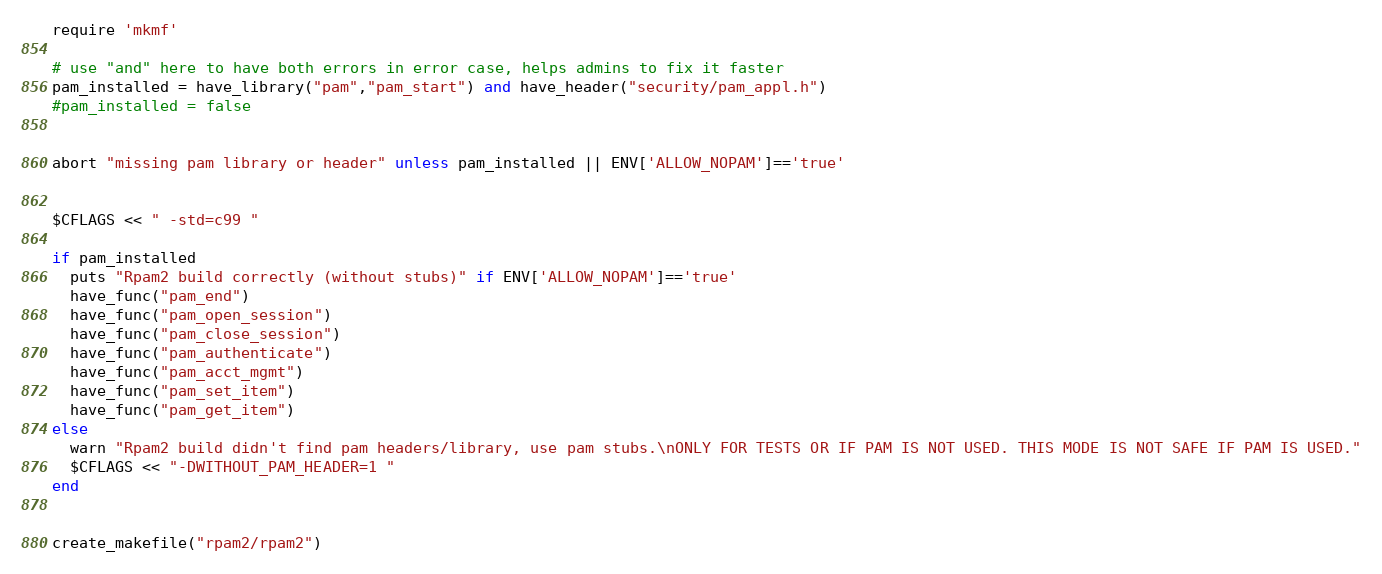Convert code to text. <code><loc_0><loc_0><loc_500><loc_500><_Ruby_>require 'mkmf'

# use "and" here to have both errors in error case, helps admins to fix it faster
pam_installed = have_library("pam","pam_start") and have_header("security/pam_appl.h")
#pam_installed = false


abort "missing pam library or header" unless pam_installed || ENV['ALLOW_NOPAM']=='true'


$CFLAGS << " -std=c99 "

if pam_installed
  puts "Rpam2 build correctly (without stubs)" if ENV['ALLOW_NOPAM']=='true'
  have_func("pam_end")
  have_func("pam_open_session")
  have_func("pam_close_session")
  have_func("pam_authenticate")
  have_func("pam_acct_mgmt")
  have_func("pam_set_item")
  have_func("pam_get_item")
else
  warn "Rpam2 build didn't find pam headers/library, use pam stubs.\nONLY FOR TESTS OR IF PAM IS NOT USED. THIS MODE IS NOT SAFE IF PAM IS USED."
  $CFLAGS << "-DWITHOUT_PAM_HEADER=1 "
end


create_makefile("rpam2/rpam2")
</code> 